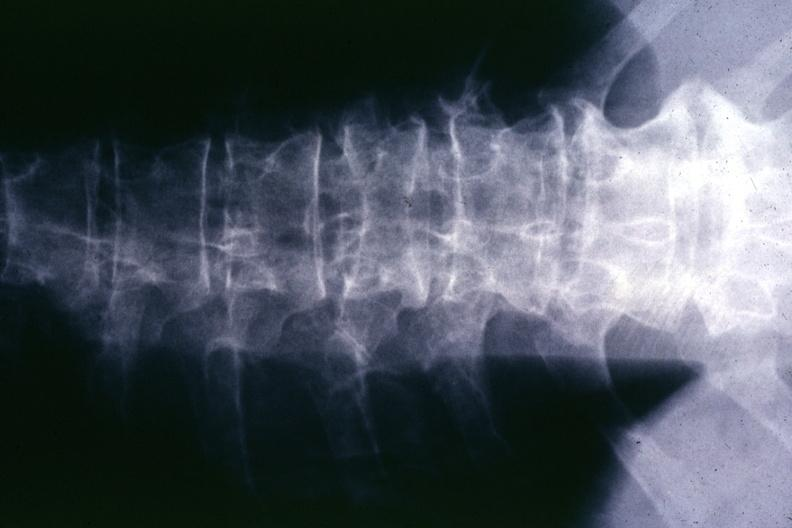does this image show x-ray multiple punched out areas and compression fracture?
Answer the question using a single word or phrase. Yes 